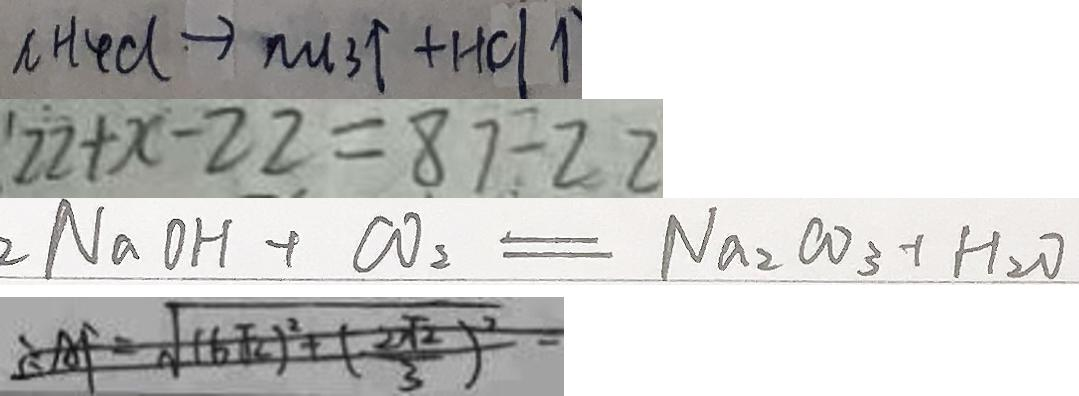<formula> <loc_0><loc_0><loc_500><loc_500>n H _ { 4 } d \rightarrow m _ { 3 } \uparrow + H C l \uparrow 
 2 2 + x - 2 2 = 8 7 \div 2 2 
 2 N a O H + C O _ { 2 } = N a _ { 2 } C O _ { 3 } + H _ { 2 } O 
 \therefore A F = \sqrt { ( 6 \sqrt { 2 } ) ^ { 2 } + ( \frac { 2 \sqrt { 2 } } { 3 } ) ^ { 2 } }</formula> 